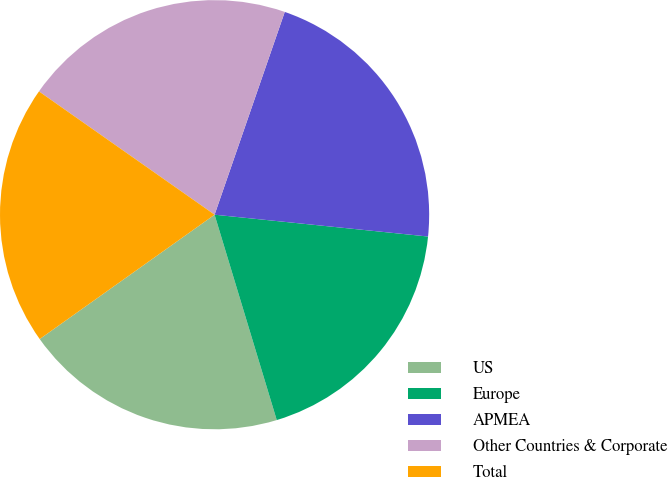<chart> <loc_0><loc_0><loc_500><loc_500><pie_chart><fcel>US<fcel>Europe<fcel>APMEA<fcel>Other Countries & Corporate<fcel>Total<nl><fcel>19.84%<fcel>18.7%<fcel>21.32%<fcel>20.56%<fcel>19.58%<nl></chart> 